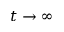<formula> <loc_0><loc_0><loc_500><loc_500>t \rightarrow \infty</formula> 